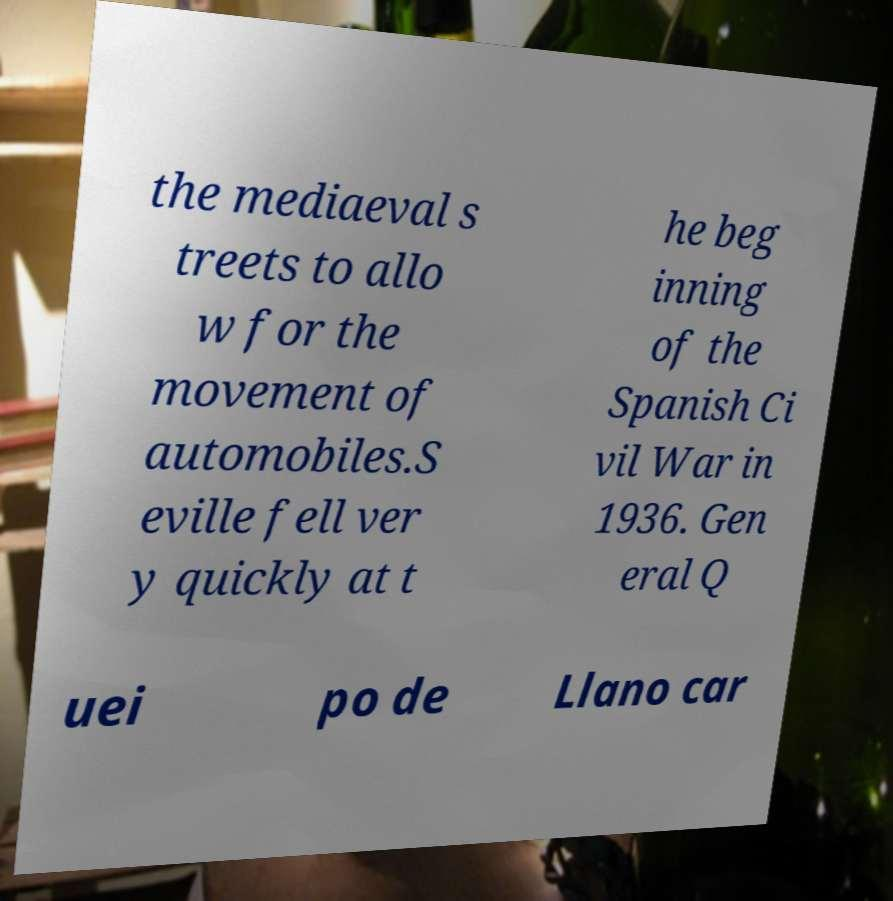Could you extract and type out the text from this image? the mediaeval s treets to allo w for the movement of automobiles.S eville fell ver y quickly at t he beg inning of the Spanish Ci vil War in 1936. Gen eral Q uei po de Llano car 